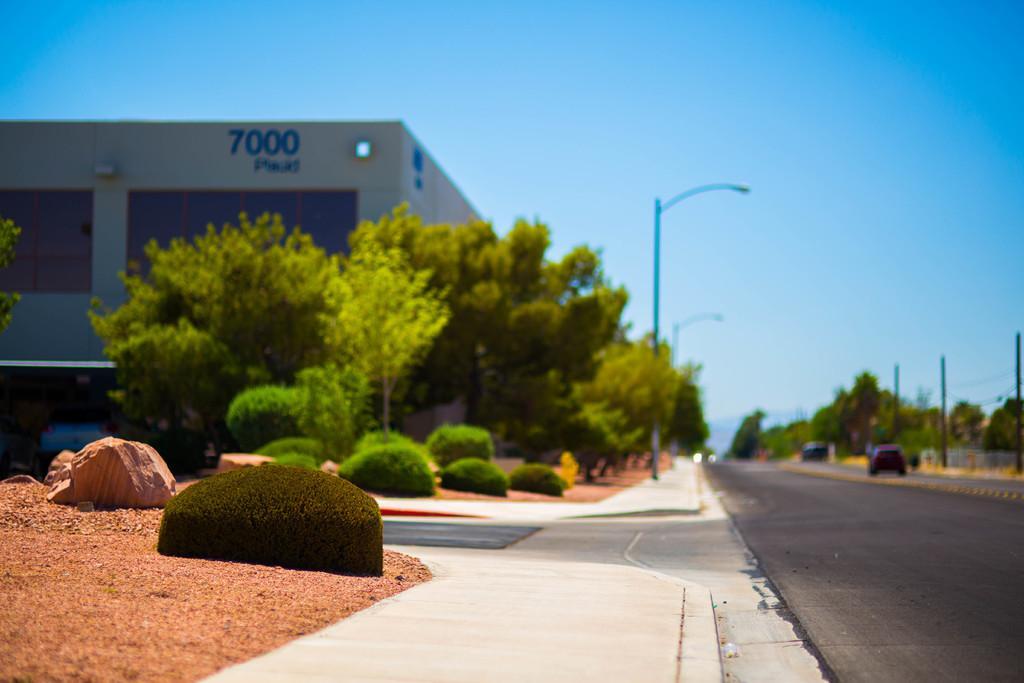Please provide a concise description of this image. In this picture there is a building on the left side of the image. On the left and on the right side of the image there are trees and there are poles on the footpath. On the right side of the image there are vehicles on the road. At the top there is sky. At the bottom there is a road and there are plants and stones on the mud. 